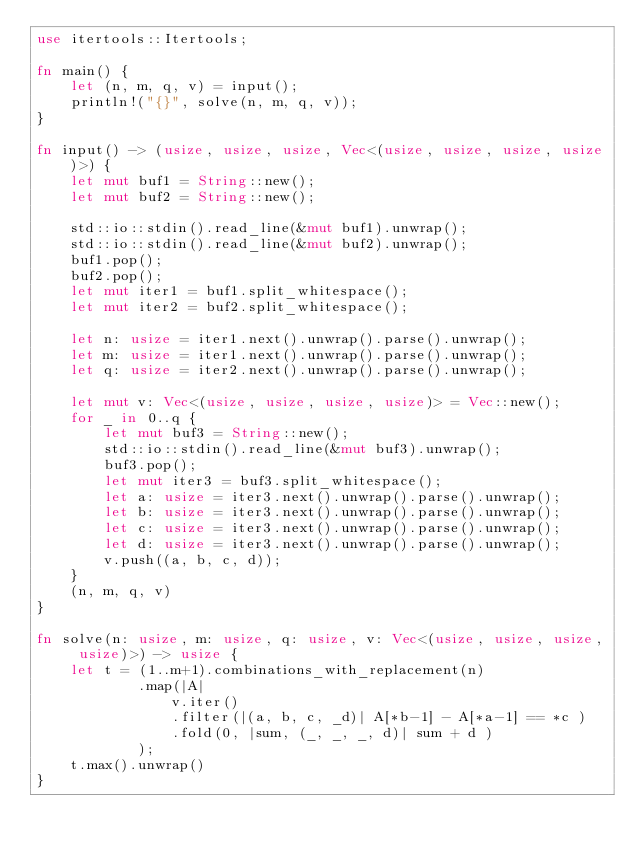Convert code to text. <code><loc_0><loc_0><loc_500><loc_500><_Rust_>use itertools::Itertools;

fn main() {
    let (n, m, q, v) = input();
    println!("{}", solve(n, m, q, v));
}

fn input() -> (usize, usize, usize, Vec<(usize, usize, usize, usize)>) {
    let mut buf1 = String::new();
    let mut buf2 = String::new();
    
    std::io::stdin().read_line(&mut buf1).unwrap();
    std::io::stdin().read_line(&mut buf2).unwrap();
    buf1.pop();
    buf2.pop();
    let mut iter1 = buf1.split_whitespace();
    let mut iter2 = buf2.split_whitespace();

    let n: usize = iter1.next().unwrap().parse().unwrap();
    let m: usize = iter1.next().unwrap().parse().unwrap();
    let q: usize = iter2.next().unwrap().parse().unwrap();

    let mut v: Vec<(usize, usize, usize, usize)> = Vec::new();
    for _ in 0..q {
        let mut buf3 = String::new();
        std::io::stdin().read_line(&mut buf3).unwrap();
        buf3.pop();
        let mut iter3 = buf3.split_whitespace();
        let a: usize = iter3.next().unwrap().parse().unwrap();
        let b: usize = iter3.next().unwrap().parse().unwrap();
        let c: usize = iter3.next().unwrap().parse().unwrap();
        let d: usize = iter3.next().unwrap().parse().unwrap();
        v.push((a, b, c, d));
    }
    (n, m, q, v)
}

fn solve(n: usize, m: usize, q: usize, v: Vec<(usize, usize, usize, usize)>) -> usize {
    let t = (1..m+1).combinations_with_replacement(n)
            .map(|A| 
                v.iter()
                .filter(|(a, b, c, _d)| A[*b-1] - A[*a-1] == *c )
                .fold(0, |sum, (_, _, _, d)| sum + d )
            );
    t.max().unwrap()
}</code> 